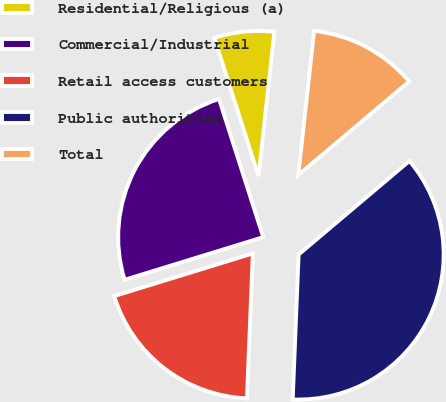Convert chart to OTSL. <chart><loc_0><loc_0><loc_500><loc_500><pie_chart><fcel>Residential/Religious (a)<fcel>Commercial/Industrial<fcel>Retail access customers<fcel>Public authorities<fcel>Total<nl><fcel>6.67%<fcel>24.82%<fcel>19.6%<fcel>36.81%<fcel>12.1%<nl></chart> 